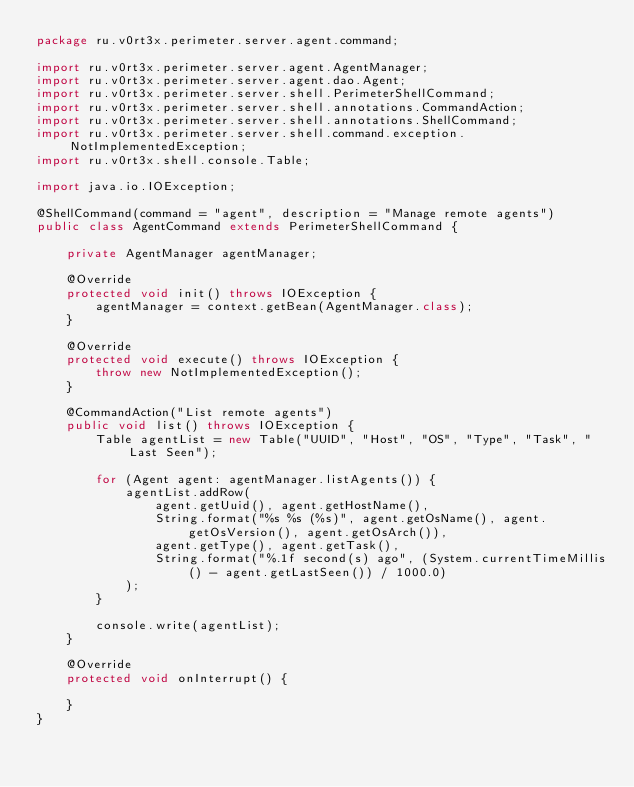<code> <loc_0><loc_0><loc_500><loc_500><_Java_>package ru.v0rt3x.perimeter.server.agent.command;

import ru.v0rt3x.perimeter.server.agent.AgentManager;
import ru.v0rt3x.perimeter.server.agent.dao.Agent;
import ru.v0rt3x.perimeter.server.shell.PerimeterShellCommand;
import ru.v0rt3x.perimeter.server.shell.annotations.CommandAction;
import ru.v0rt3x.perimeter.server.shell.annotations.ShellCommand;
import ru.v0rt3x.perimeter.server.shell.command.exception.NotImplementedException;
import ru.v0rt3x.shell.console.Table;

import java.io.IOException;

@ShellCommand(command = "agent", description = "Manage remote agents")
public class AgentCommand extends PerimeterShellCommand {

    private AgentManager agentManager;

    @Override
    protected void init() throws IOException {
        agentManager = context.getBean(AgentManager.class);
    }

    @Override
    protected void execute() throws IOException {
        throw new NotImplementedException();
    }

    @CommandAction("List remote agents")
    public void list() throws IOException {
        Table agentList = new Table("UUID", "Host", "OS", "Type", "Task", "Last Seen");

        for (Agent agent: agentManager.listAgents()) {
            agentList.addRow(
                agent.getUuid(), agent.getHostName(),
                String.format("%s %s (%s)", agent.getOsName(), agent.getOsVersion(), agent.getOsArch()),
                agent.getType(), agent.getTask(),
                String.format("%.1f second(s) ago", (System.currentTimeMillis() - agent.getLastSeen()) / 1000.0)
            );
        }

        console.write(agentList);
    }

    @Override
    protected void onInterrupt() {

    }
}
</code> 